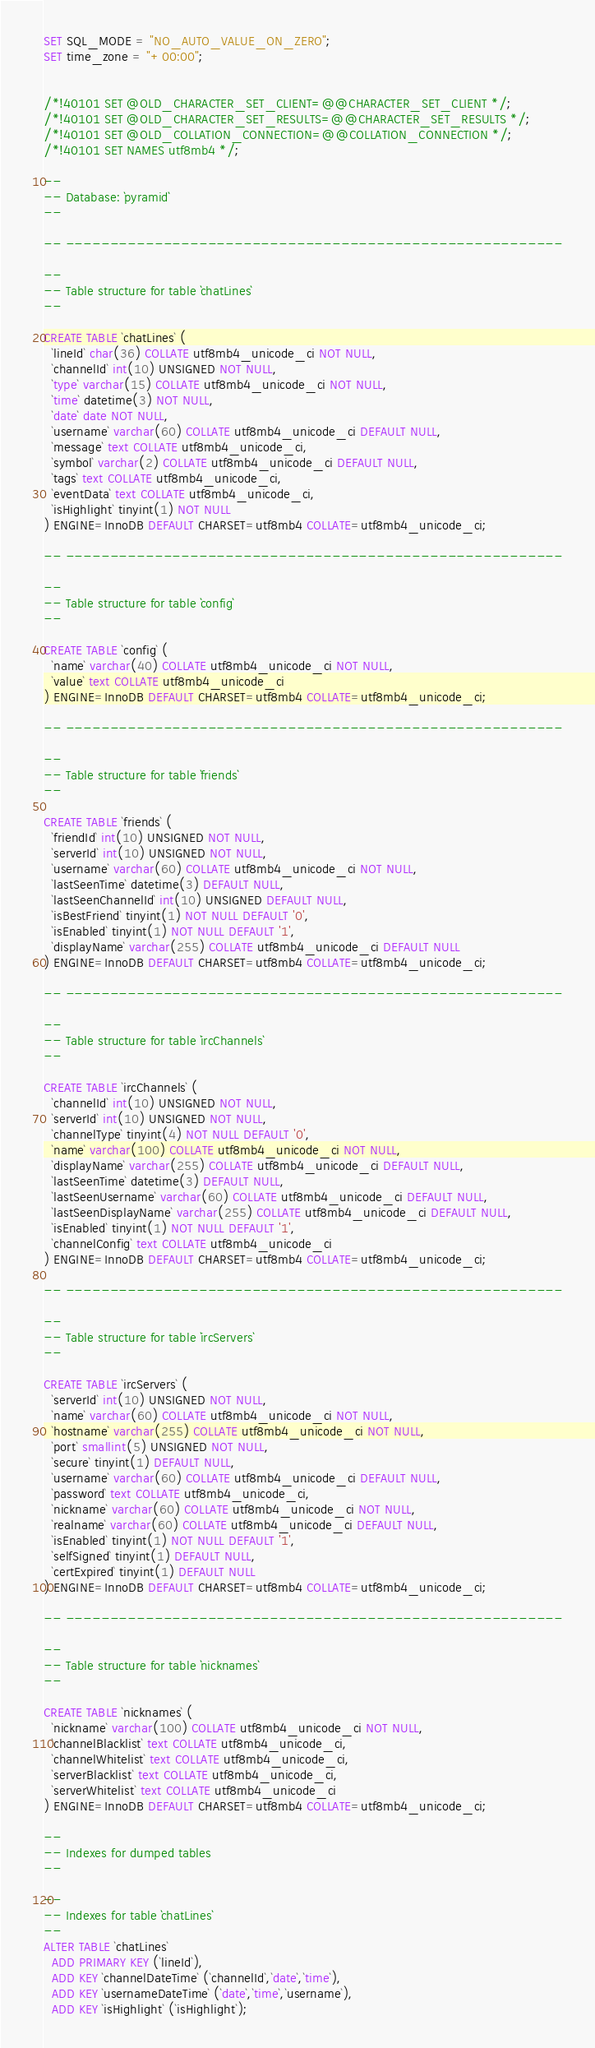Convert code to text. <code><loc_0><loc_0><loc_500><loc_500><_SQL_>SET SQL_MODE = "NO_AUTO_VALUE_ON_ZERO";
SET time_zone = "+00:00";


/*!40101 SET @OLD_CHARACTER_SET_CLIENT=@@CHARACTER_SET_CLIENT */;
/*!40101 SET @OLD_CHARACTER_SET_RESULTS=@@CHARACTER_SET_RESULTS */;
/*!40101 SET @OLD_COLLATION_CONNECTION=@@COLLATION_CONNECTION */;
/*!40101 SET NAMES utf8mb4 */;

--
-- Database: `pyramid`
--

-- --------------------------------------------------------

--
-- Table structure for table `chatLines`
--

CREATE TABLE `chatLines` (
  `lineId` char(36) COLLATE utf8mb4_unicode_ci NOT NULL,
  `channelId` int(10) UNSIGNED NOT NULL,
  `type` varchar(15) COLLATE utf8mb4_unicode_ci NOT NULL,
  `time` datetime(3) NOT NULL,
  `date` date NOT NULL,
  `username` varchar(60) COLLATE utf8mb4_unicode_ci DEFAULT NULL,
  `message` text COLLATE utf8mb4_unicode_ci,
  `symbol` varchar(2) COLLATE utf8mb4_unicode_ci DEFAULT NULL,
  `tags` text COLLATE utf8mb4_unicode_ci,
  `eventData` text COLLATE utf8mb4_unicode_ci,
  `isHighlight` tinyint(1) NOT NULL
) ENGINE=InnoDB DEFAULT CHARSET=utf8mb4 COLLATE=utf8mb4_unicode_ci;

-- --------------------------------------------------------

--
-- Table structure for table `config`
--

CREATE TABLE `config` (
  `name` varchar(40) COLLATE utf8mb4_unicode_ci NOT NULL,
  `value` text COLLATE utf8mb4_unicode_ci
) ENGINE=InnoDB DEFAULT CHARSET=utf8mb4 COLLATE=utf8mb4_unicode_ci;

-- --------------------------------------------------------

--
-- Table structure for table `friends`
--

CREATE TABLE `friends` (
  `friendId` int(10) UNSIGNED NOT NULL,
  `serverId` int(10) UNSIGNED NOT NULL,
  `username` varchar(60) COLLATE utf8mb4_unicode_ci NOT NULL,
  `lastSeenTime` datetime(3) DEFAULT NULL,
  `lastSeenChannelId` int(10) UNSIGNED DEFAULT NULL,
  `isBestFriend` tinyint(1) NOT NULL DEFAULT '0',
  `isEnabled` tinyint(1) NOT NULL DEFAULT '1',
  `displayName` varchar(255) COLLATE utf8mb4_unicode_ci DEFAULT NULL
) ENGINE=InnoDB DEFAULT CHARSET=utf8mb4 COLLATE=utf8mb4_unicode_ci;

-- --------------------------------------------------------

--
-- Table structure for table `ircChannels`
--

CREATE TABLE `ircChannels` (
  `channelId` int(10) UNSIGNED NOT NULL,
  `serverId` int(10) UNSIGNED NOT NULL,
  `channelType` tinyint(4) NOT NULL DEFAULT '0',
  `name` varchar(100) COLLATE utf8mb4_unicode_ci NOT NULL,
  `displayName` varchar(255) COLLATE utf8mb4_unicode_ci DEFAULT NULL,
  `lastSeenTime` datetime(3) DEFAULT NULL,
  `lastSeenUsername` varchar(60) COLLATE utf8mb4_unicode_ci DEFAULT NULL,
  `lastSeenDisplayName` varchar(255) COLLATE utf8mb4_unicode_ci DEFAULT NULL,
  `isEnabled` tinyint(1) NOT NULL DEFAULT '1',
  `channelConfig` text COLLATE utf8mb4_unicode_ci
) ENGINE=InnoDB DEFAULT CHARSET=utf8mb4 COLLATE=utf8mb4_unicode_ci;

-- --------------------------------------------------------

--
-- Table structure for table `ircServers`
--

CREATE TABLE `ircServers` (
  `serverId` int(10) UNSIGNED NOT NULL,
  `name` varchar(60) COLLATE utf8mb4_unicode_ci NOT NULL,
  `hostname` varchar(255) COLLATE utf8mb4_unicode_ci NOT NULL,
  `port` smallint(5) UNSIGNED NOT NULL,
  `secure` tinyint(1) DEFAULT NULL,
  `username` varchar(60) COLLATE utf8mb4_unicode_ci DEFAULT NULL,
  `password` text COLLATE utf8mb4_unicode_ci,
  `nickname` varchar(60) COLLATE utf8mb4_unicode_ci NOT NULL,
  `realname` varchar(60) COLLATE utf8mb4_unicode_ci DEFAULT NULL,
  `isEnabled` tinyint(1) NOT NULL DEFAULT '1',
  `selfSigned` tinyint(1) DEFAULT NULL,
  `certExpired` tinyint(1) DEFAULT NULL
) ENGINE=InnoDB DEFAULT CHARSET=utf8mb4 COLLATE=utf8mb4_unicode_ci;

-- --------------------------------------------------------

--
-- Table structure for table `nicknames`
--

CREATE TABLE `nicknames` (
  `nickname` varchar(100) COLLATE utf8mb4_unicode_ci NOT NULL,
  `channelBlacklist` text COLLATE utf8mb4_unicode_ci,
  `channelWhitelist` text COLLATE utf8mb4_unicode_ci,
  `serverBlacklist` text COLLATE utf8mb4_unicode_ci,
  `serverWhitelist` text COLLATE utf8mb4_unicode_ci
) ENGINE=InnoDB DEFAULT CHARSET=utf8mb4 COLLATE=utf8mb4_unicode_ci;

--
-- Indexes for dumped tables
--

--
-- Indexes for table `chatLines`
--
ALTER TABLE `chatLines`
  ADD PRIMARY KEY (`lineId`),
  ADD KEY `channelDateTime` (`channelId`,`date`,`time`),
  ADD KEY `usernameDateTime` (`date`,`time`,`username`),
  ADD KEY `isHighlight` (`isHighlight`);
</code> 